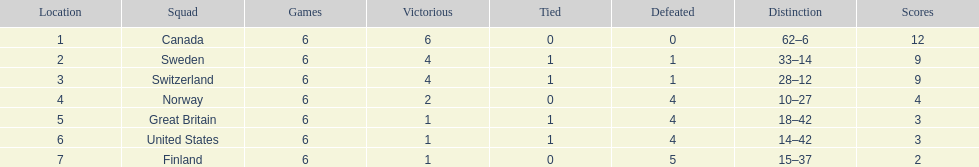How many teams won only 1 match? 3. 